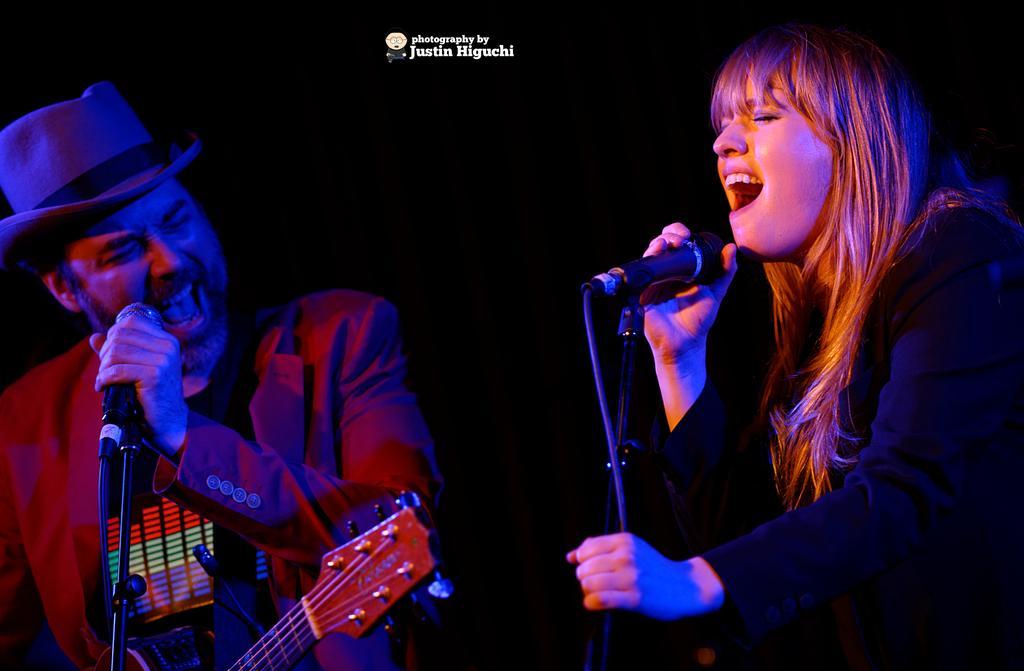Can you describe this image briefly? Background is completely dark. We can see a women and a man standing in front of a mike and singing. We can see a guitar here. 